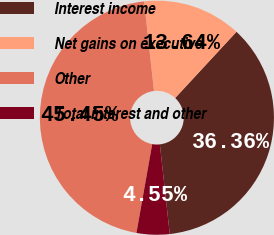<chart> <loc_0><loc_0><loc_500><loc_500><pie_chart><fcel>Interest income<fcel>Net gains on executive<fcel>Other<fcel>Total interest and other<nl><fcel>36.36%<fcel>13.64%<fcel>45.45%<fcel>4.55%<nl></chart> 